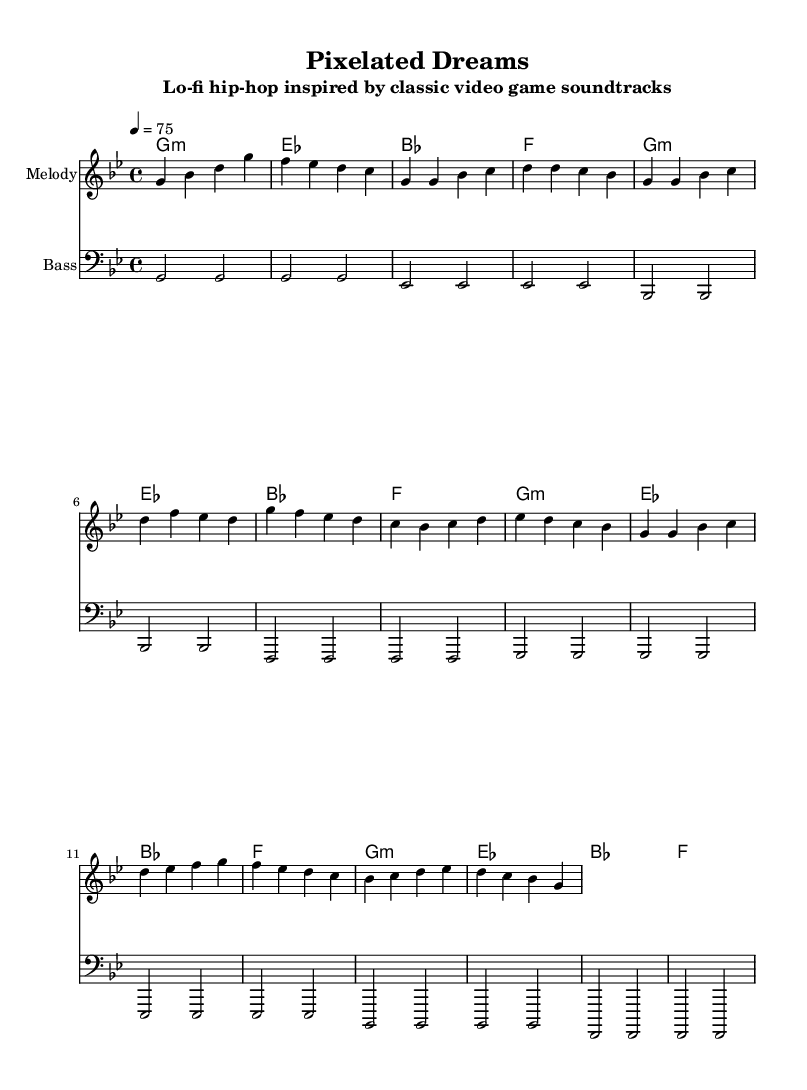What is the key signature of this music? The key signature indicated is G minor, which has two flats (B flat and E flat). This can be confirmed from the key signature markings at the beginning of the sheet music.
Answer: G minor What is the time signature of this music? The time signature is 4/4, as indicated by the notation at the beginning of the score. This means there are four beats per measure and the quarter note gets one beat.
Answer: 4/4 What is the tempo marking for this piece? The tempo marking is "4 = 75", meaning there are 75 beats per minute, and the quarter note gets one beat. This tempo is indicated in the header section of the music.
Answer: 75 How many measures are in the melody section? The melody section includes a total of 8 measures in the verse followed by 4 measures in the chorus and 4 in the bridge, summing up to 16 measures in total. This can be deduced by counting the measures in each section of the melody.
Answer: 16 Which chords are used in the harmonies? The chords used in the harmonies are G minor, E flat, B flat, and F, as shown sequentially in the chord names section of the score. Each chord is represented in the chord mode notation.
Answer: G minor, E flat, B flat, F What is the clef used for the bass part? The clef used for the bass part is the bass clef, as indicated by the specified clef at the beginning of the bass staff. The bass clef is typically used for lower-pitched instruments.
Answer: Bass clef What genre does this music belong to? The genre of the music is Lo-fi hip-hop, as stated in the subtitle of the sheet music, indicating the style and aesthetic influence of the track.
Answer: Lo-fi hip-hop 